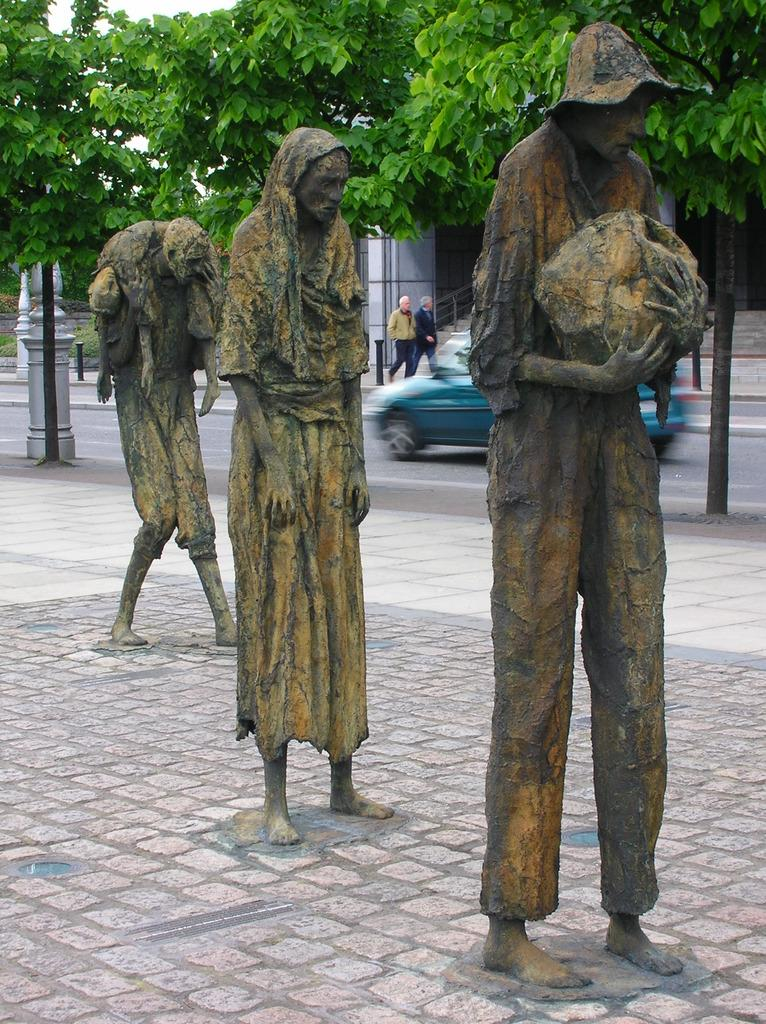What is the main subject in the center of the image? There are statues in the center of the image. Where are the statues located? The statues are on the ground. What can be seen in the background of the image? There are trees, a car, a road, persons, and a building visible in the background of the image. Can you tell me how many corks are on the statues in the image? There are no corks present on the statues in the image. What type of animals are in the zoo in the image? There is no zoo present in the image; it features statues, trees, a car, a road, persons, and a building in the background. 